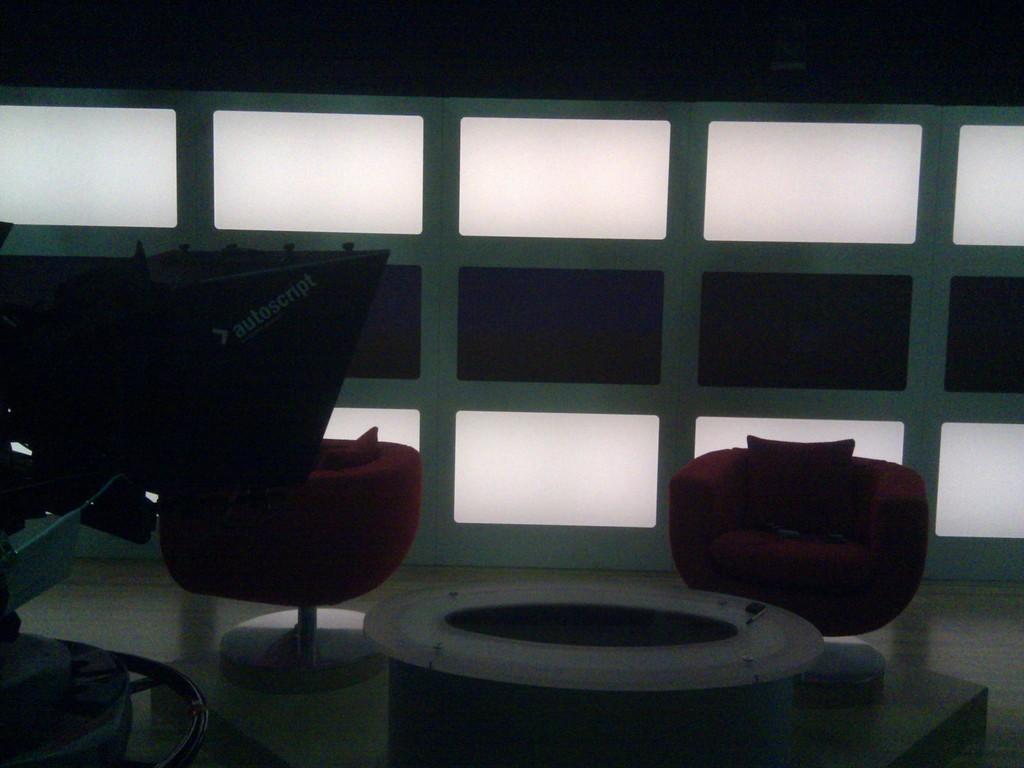Can you describe this image briefly? In this image inside a room there are two chairs. Here is a table. This is looking like a machine. In the background on the wall there are lights. 